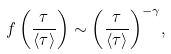Convert formula to latex. <formula><loc_0><loc_0><loc_500><loc_500>f \left ( \frac { \tau } { \langle \tau \rangle } \right ) \sim { \left ( \frac { \tau } { \langle \tau \rangle } \right ) } ^ { - \gamma } ,</formula> 